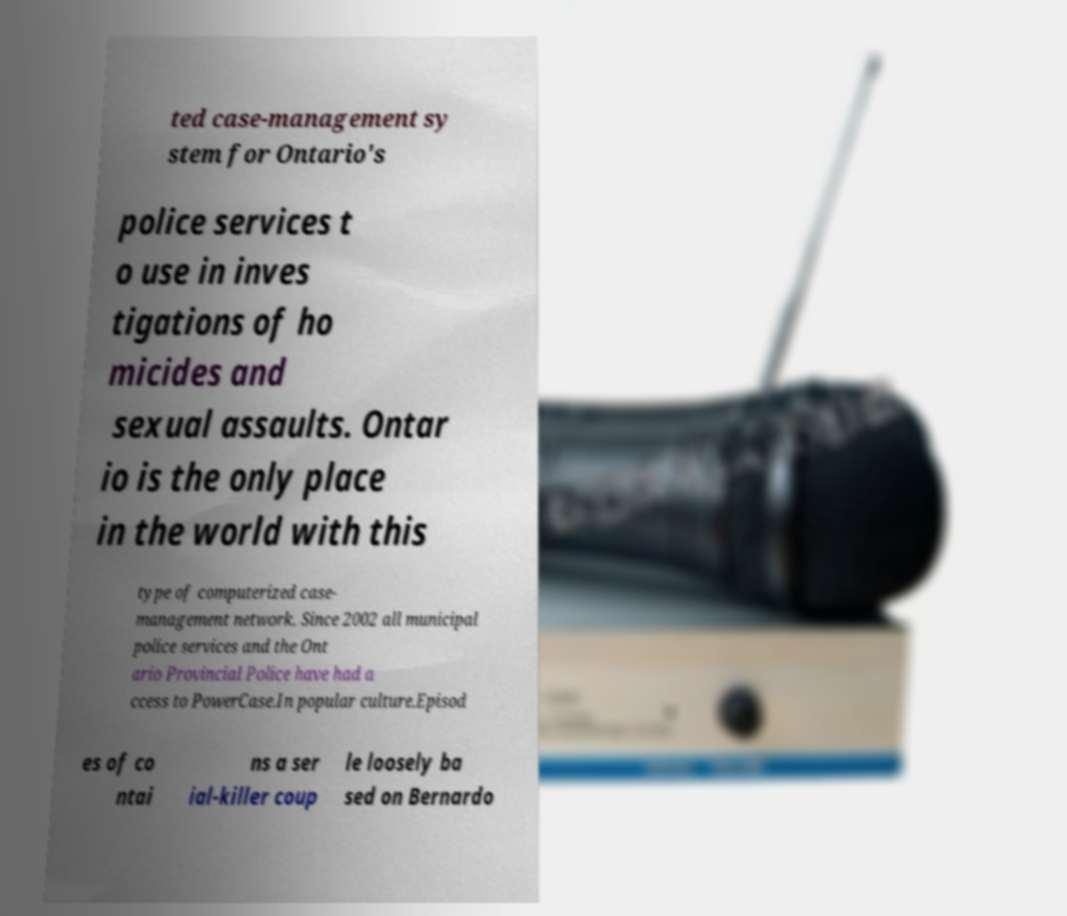What messages or text are displayed in this image? I need them in a readable, typed format. ted case-management sy stem for Ontario's police services t o use in inves tigations of ho micides and sexual assaults. Ontar io is the only place in the world with this type of computerized case- management network. Since 2002 all municipal police services and the Ont ario Provincial Police have had a ccess to PowerCase.In popular culture.Episod es of co ntai ns a ser ial-killer coup le loosely ba sed on Bernardo 